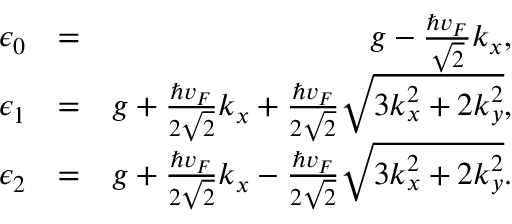Convert formula to latex. <formula><loc_0><loc_0><loc_500><loc_500>\begin{array} { r l r } { \epsilon _ { 0 } } & { = } & { g - \frac { \hbar { v } _ { F } } { \sqrt { 2 } } k _ { x } , } \\ { \epsilon _ { 1 } } & { = } & { g + \frac { \hbar { v } _ { F } } { 2 \sqrt { 2 } } k _ { x } + \frac { \hbar { v } _ { F } } { 2 \sqrt { 2 } } \sqrt { 3 k _ { x } ^ { 2 } + 2 k _ { y } ^ { 2 } } , } \\ { \epsilon _ { 2 } } & { = } & { g + \frac { \hbar { v } _ { F } } { 2 \sqrt { 2 } } k _ { x } - \frac { \hbar { v } _ { F } } { 2 \sqrt { 2 } } \sqrt { 3 k _ { x } ^ { 2 } + 2 k _ { y } ^ { 2 } } . } \end{array}</formula> 